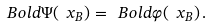<formula> <loc_0><loc_0><loc_500><loc_500>\ B o l d { \Psi } ( \ x _ { B } ) = \ B o l d { \varphi } ( \ x _ { B } ) \, .</formula> 